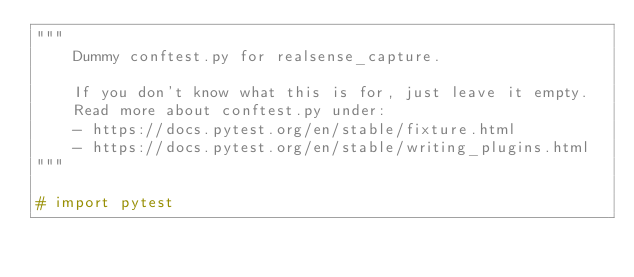Convert code to text. <code><loc_0><loc_0><loc_500><loc_500><_Python_>"""
    Dummy conftest.py for realsense_capture.

    If you don't know what this is for, just leave it empty.
    Read more about conftest.py under:
    - https://docs.pytest.org/en/stable/fixture.html
    - https://docs.pytest.org/en/stable/writing_plugins.html
"""

# import pytest
</code> 